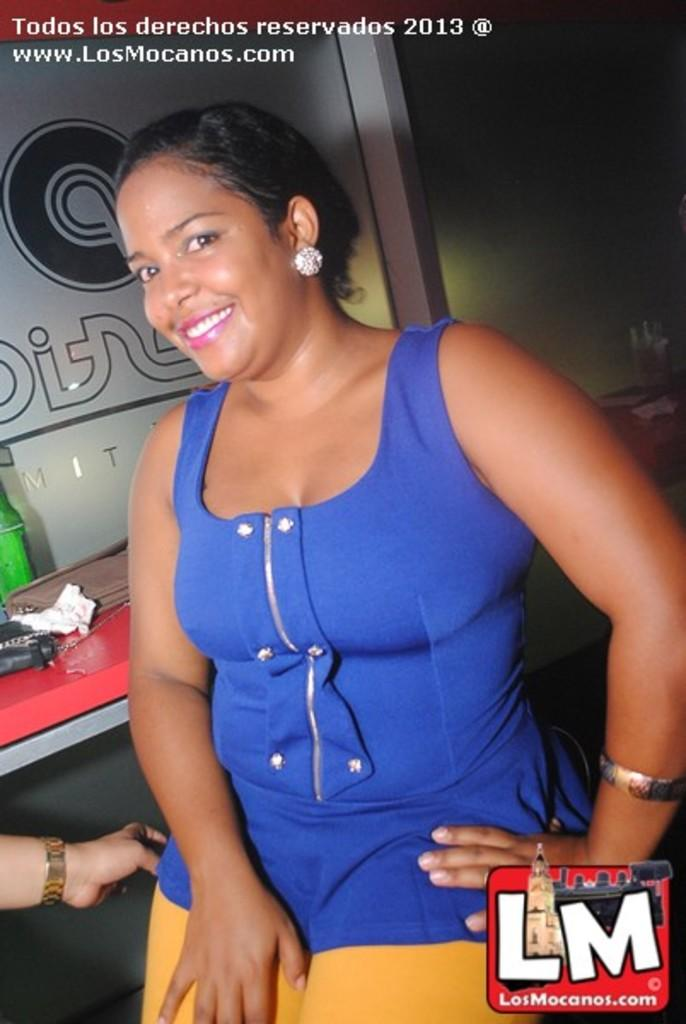<image>
Give a short and clear explanation of the subsequent image. A woman in a blue shirt is being photographed for the news website www.LosMocanos.com 